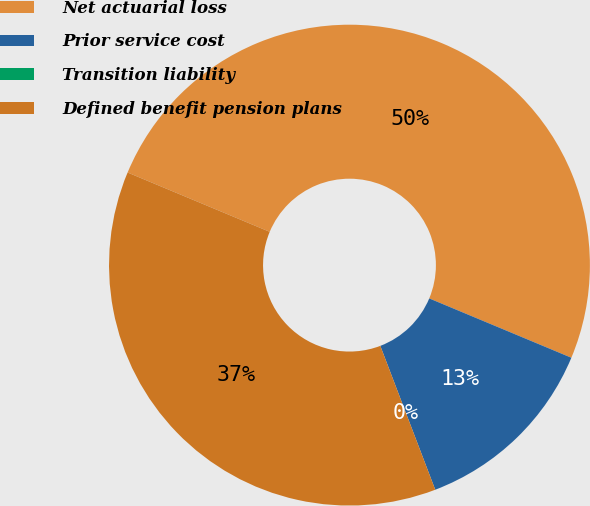Convert chart. <chart><loc_0><loc_0><loc_500><loc_500><pie_chart><fcel>Net actuarial loss<fcel>Prior service cost<fcel>Transition liability<fcel>Defined benefit pension plans<nl><fcel>50.0%<fcel>12.9%<fcel>0.0%<fcel>37.1%<nl></chart> 